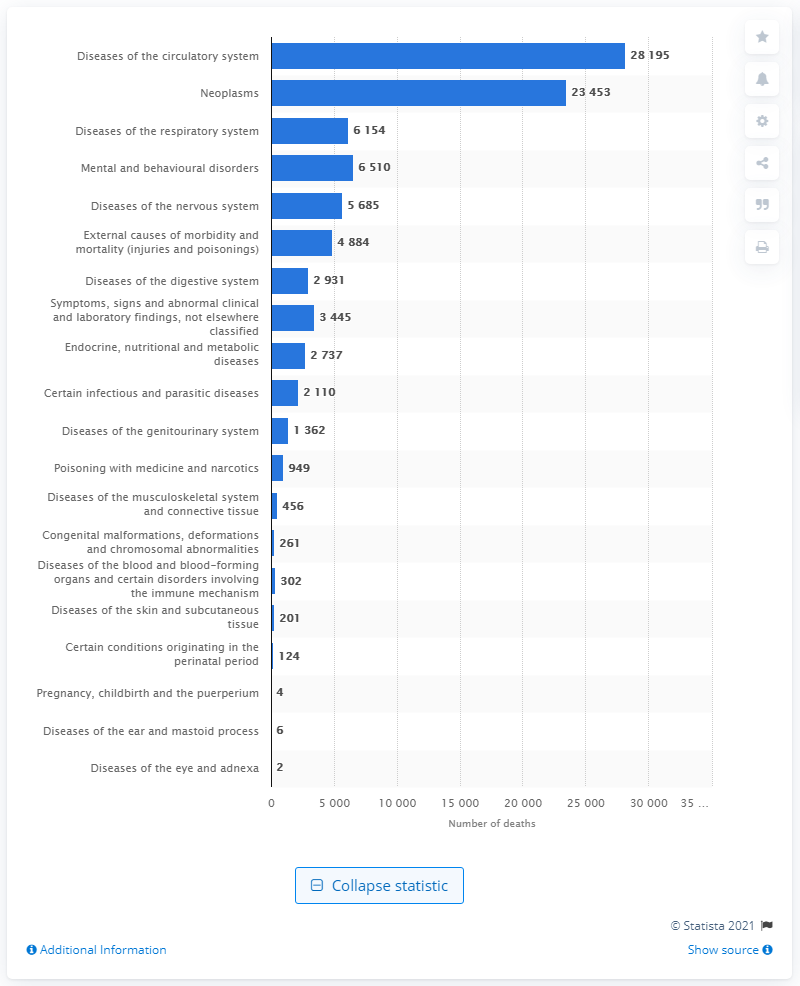List a handful of essential elements in this visual. In 2019, a total of 28,195 deaths were caused by diseases in the circulatory system in Sweden. 